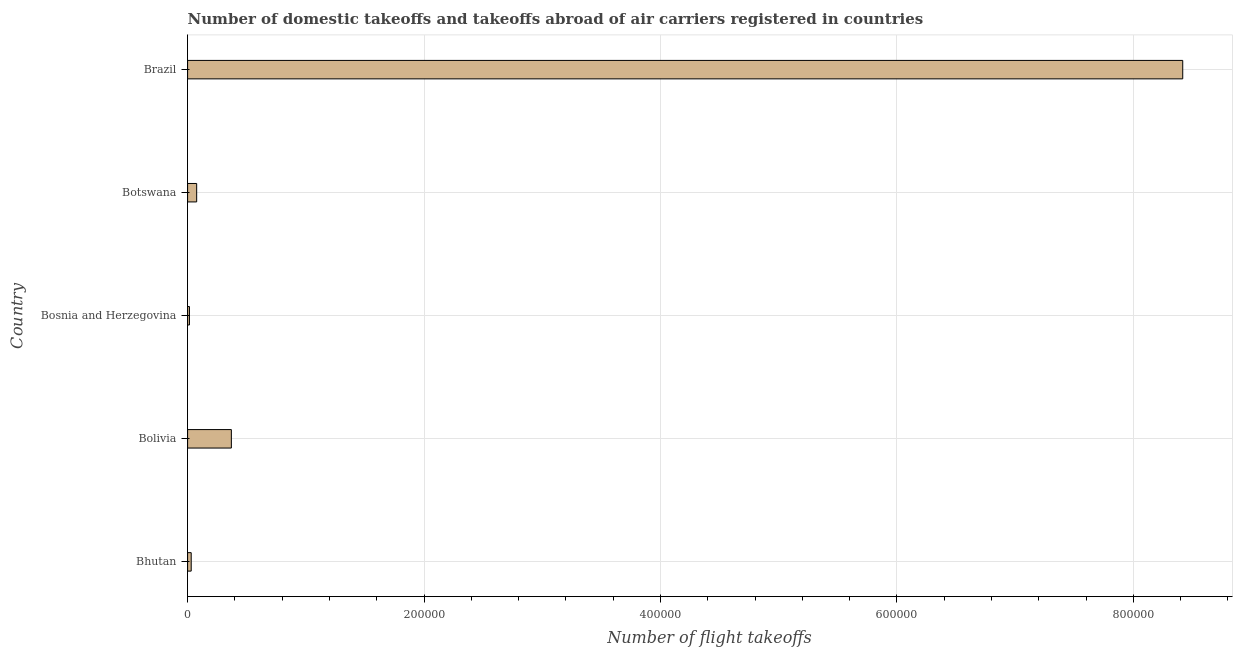What is the title of the graph?
Your answer should be compact. Number of domestic takeoffs and takeoffs abroad of air carriers registered in countries. What is the label or title of the X-axis?
Give a very brief answer. Number of flight takeoffs. What is the number of flight takeoffs in Bhutan?
Provide a short and direct response. 3053.4. Across all countries, what is the maximum number of flight takeoffs?
Your response must be concise. 8.42e+05. Across all countries, what is the minimum number of flight takeoffs?
Make the answer very short. 1573.55. In which country was the number of flight takeoffs minimum?
Give a very brief answer. Bosnia and Herzegovina. What is the sum of the number of flight takeoffs?
Offer a terse response. 8.91e+05. What is the difference between the number of flight takeoffs in Bhutan and Bosnia and Herzegovina?
Offer a terse response. 1479.85. What is the average number of flight takeoffs per country?
Offer a very short reply. 1.78e+05. What is the median number of flight takeoffs?
Offer a very short reply. 7681. In how many countries, is the number of flight takeoffs greater than 200000 ?
Give a very brief answer. 1. What is the ratio of the number of flight takeoffs in Bosnia and Herzegovina to that in Botswana?
Offer a very short reply. 0.2. Is the number of flight takeoffs in Bolivia less than that in Bosnia and Herzegovina?
Offer a terse response. No. What is the difference between the highest and the second highest number of flight takeoffs?
Give a very brief answer. 8.05e+05. What is the difference between the highest and the lowest number of flight takeoffs?
Keep it short and to the point. 8.40e+05. How many countries are there in the graph?
Your response must be concise. 5. Are the values on the major ticks of X-axis written in scientific E-notation?
Provide a succinct answer. No. What is the Number of flight takeoffs of Bhutan?
Provide a short and direct response. 3053.4. What is the Number of flight takeoffs in Bolivia?
Offer a terse response. 3.70e+04. What is the Number of flight takeoffs of Bosnia and Herzegovina?
Your answer should be very brief. 1573.55. What is the Number of flight takeoffs in Botswana?
Offer a very short reply. 7681. What is the Number of flight takeoffs of Brazil?
Give a very brief answer. 8.42e+05. What is the difference between the Number of flight takeoffs in Bhutan and Bolivia?
Your answer should be compact. -3.40e+04. What is the difference between the Number of flight takeoffs in Bhutan and Bosnia and Herzegovina?
Keep it short and to the point. 1479.85. What is the difference between the Number of flight takeoffs in Bhutan and Botswana?
Ensure brevity in your answer.  -4627.6. What is the difference between the Number of flight takeoffs in Bhutan and Brazil?
Your answer should be very brief. -8.39e+05. What is the difference between the Number of flight takeoffs in Bolivia and Bosnia and Herzegovina?
Keep it short and to the point. 3.54e+04. What is the difference between the Number of flight takeoffs in Bolivia and Botswana?
Ensure brevity in your answer.  2.93e+04. What is the difference between the Number of flight takeoffs in Bolivia and Brazil?
Give a very brief answer. -8.05e+05. What is the difference between the Number of flight takeoffs in Bosnia and Herzegovina and Botswana?
Provide a succinct answer. -6107.45. What is the difference between the Number of flight takeoffs in Bosnia and Herzegovina and Brazil?
Make the answer very short. -8.40e+05. What is the difference between the Number of flight takeoffs in Botswana and Brazil?
Provide a succinct answer. -8.34e+05. What is the ratio of the Number of flight takeoffs in Bhutan to that in Bolivia?
Provide a short and direct response. 0.08. What is the ratio of the Number of flight takeoffs in Bhutan to that in Bosnia and Herzegovina?
Your answer should be compact. 1.94. What is the ratio of the Number of flight takeoffs in Bhutan to that in Botswana?
Keep it short and to the point. 0.4. What is the ratio of the Number of flight takeoffs in Bhutan to that in Brazil?
Your response must be concise. 0. What is the ratio of the Number of flight takeoffs in Bolivia to that in Bosnia and Herzegovina?
Provide a short and direct response. 23.53. What is the ratio of the Number of flight takeoffs in Bolivia to that in Botswana?
Ensure brevity in your answer.  4.82. What is the ratio of the Number of flight takeoffs in Bolivia to that in Brazil?
Give a very brief answer. 0.04. What is the ratio of the Number of flight takeoffs in Bosnia and Herzegovina to that in Botswana?
Ensure brevity in your answer.  0.2. What is the ratio of the Number of flight takeoffs in Bosnia and Herzegovina to that in Brazil?
Your response must be concise. 0. What is the ratio of the Number of flight takeoffs in Botswana to that in Brazil?
Offer a terse response. 0.01. 